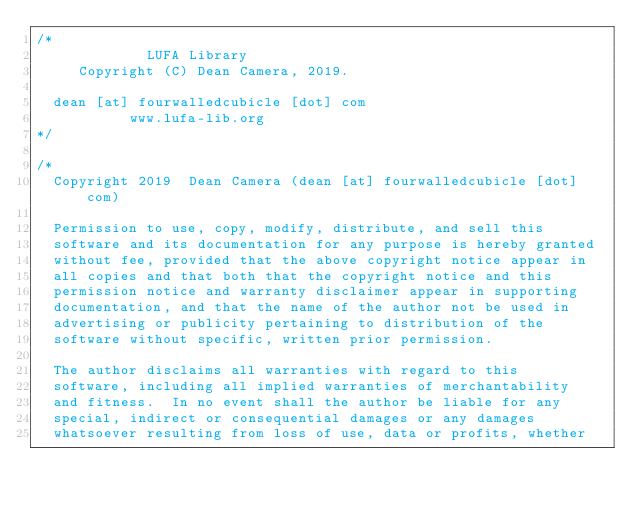Convert code to text. <code><loc_0><loc_0><loc_500><loc_500><_C_>/*
             LUFA Library
     Copyright (C) Dean Camera, 2019.

  dean [at] fourwalledcubicle [dot] com
           www.lufa-lib.org
*/

/*
  Copyright 2019  Dean Camera (dean [at] fourwalledcubicle [dot] com)

  Permission to use, copy, modify, distribute, and sell this
  software and its documentation for any purpose is hereby granted
  without fee, provided that the above copyright notice appear in
  all copies and that both that the copyright notice and this
  permission notice and warranty disclaimer appear in supporting
  documentation, and that the name of the author not be used in
  advertising or publicity pertaining to distribution of the
  software without specific, written prior permission.

  The author disclaims all warranties with regard to this
  software, including all implied warranties of merchantability
  and fitness.  In no event shall the author be liable for any
  special, indirect or consequential damages or any damages
  whatsoever resulting from loss of use, data or profits, whether</code> 